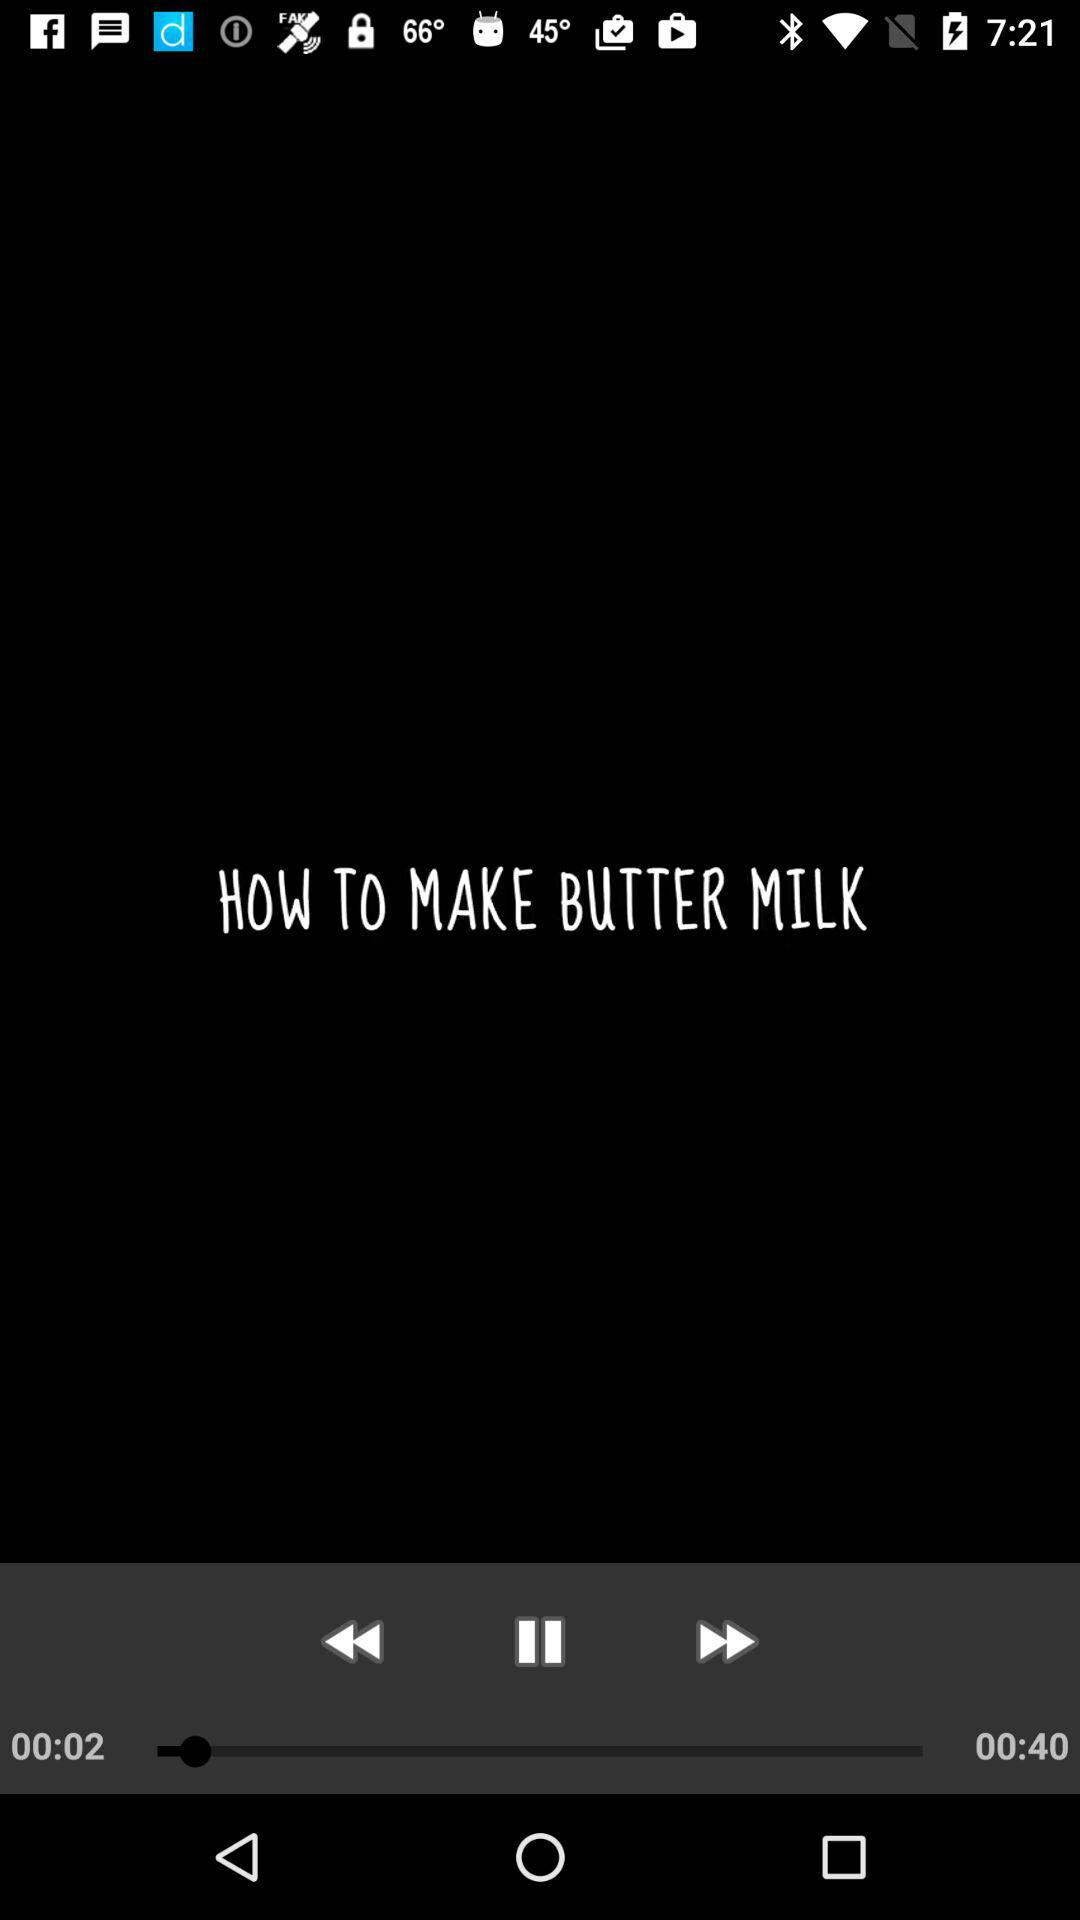How many seconds longer is the video than the title?
Answer the question using a single word or phrase. 38 